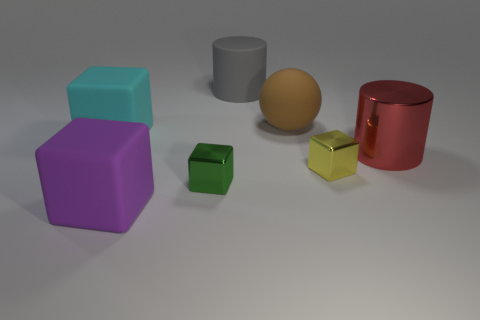Subtract all small green metal blocks. How many blocks are left? 3 Subtract all green blocks. How many blocks are left? 3 Add 1 big gray things. How many objects exist? 8 Subtract all spheres. How many objects are left? 6 Add 4 large things. How many large things are left? 9 Add 3 big brown cylinders. How many big brown cylinders exist? 3 Subtract 0 purple spheres. How many objects are left? 7 Subtract all blue cubes. Subtract all green balls. How many cubes are left? 4 Subtract all tiny purple rubber cubes. Subtract all small blocks. How many objects are left? 5 